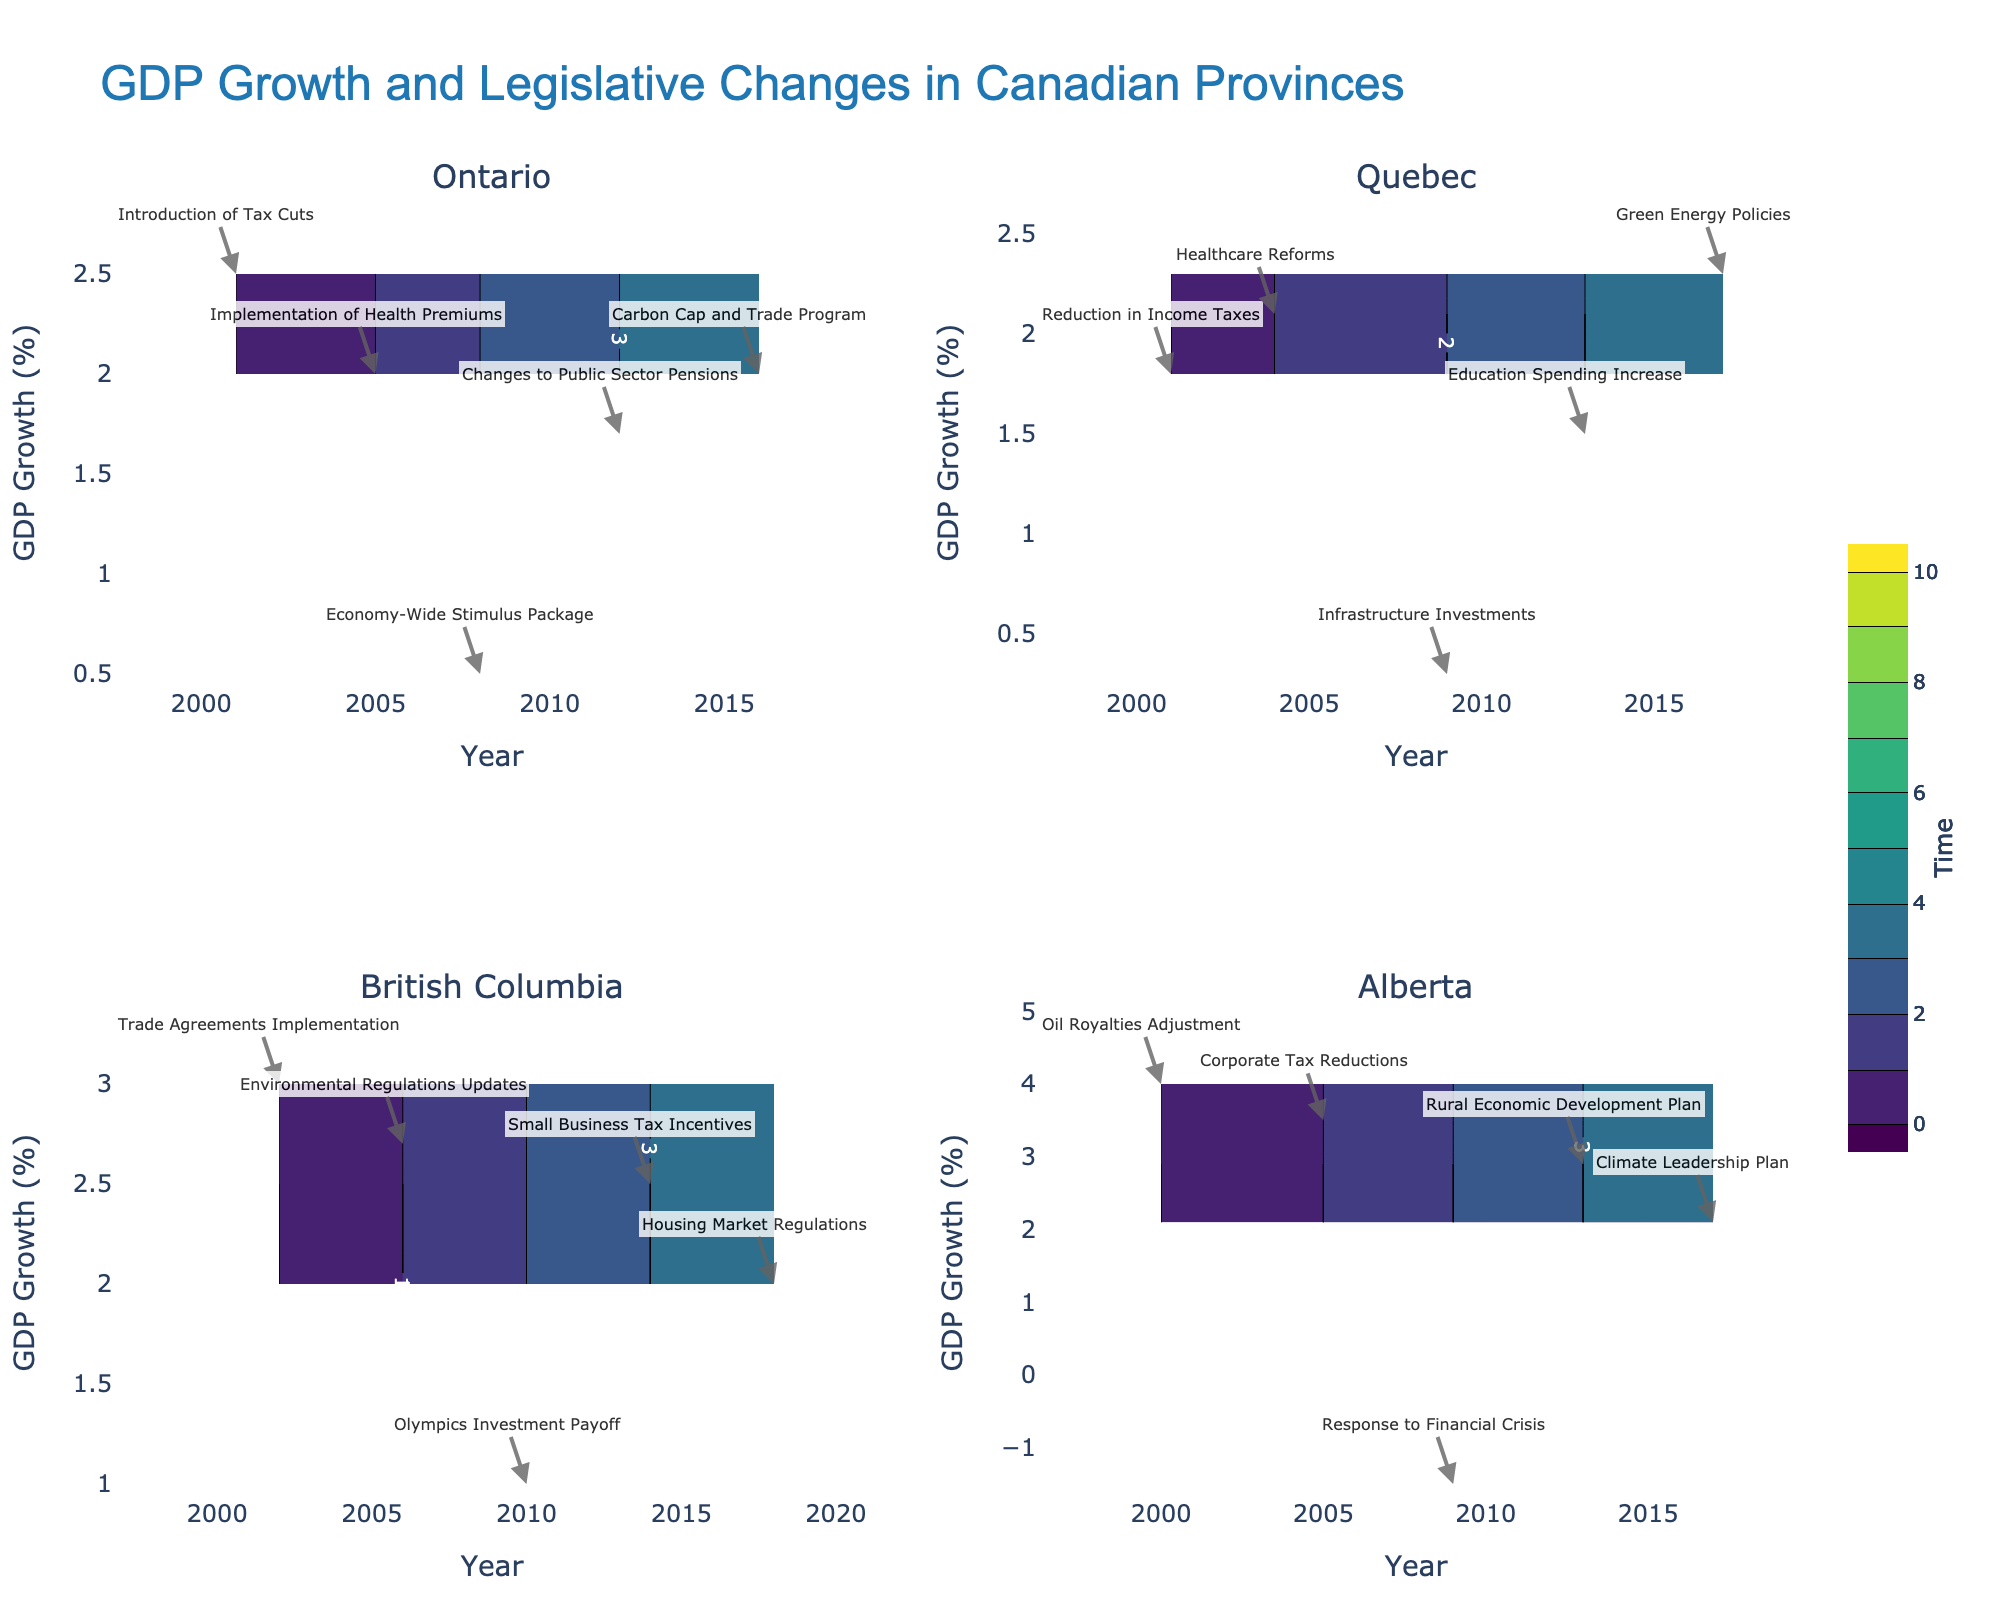What is the title of the figure? The title of the figure is displayed at the top of the chart. It reads "GDP Growth and Legislative Changes in Canadian Provinces."
Answer: GDP Growth and Legislative Changes in Canadian Provinces How many provinces' data are represented in the figure? By looking at the subplot titles, we can see there are four different provinces: Ontario, Quebec, British Columbia, and Alberta.
Answer: Four What is the color scale used in the figure? The contours are colored using the 'Viridis' color scale, a gradient of colors ranging from dark purple to yellow.
Answer: Viridis In which year did Alberta experience negative GDP growth? By examining the data points in Alberta's subplot, we see that the year corresponding to a negative GDP growth is 2009.
Answer: 2009 Which province shows the highest GDP growth rate in the figure, and what is the legislative change associated with it? Looking at the peaks of the GDP growth rates across subplots, Alberta has the highest growth rate, 4.0%, which is associated with "Oil Royalties Adjustment" in 2000.
Answer: Alberta, Oil Royalties Adjustment Comparing Ontario and Quebec, which province had a higher GDP growth rate in 2001, and by how much? In 2001, Ontario's GDP growth rate was 2.5% while Quebec's was 1.8%. The difference is 2.5% - 1.8% = 0.7%.
Answer: Ontario, 0.7% What is the average GDP growth rate for British Columbia over the years represented in the figure? British Columbia's GDP growth rates are 3.0%, 2.7%, 1.0%, 2.5%, and 2.0%. The average is calculated as (3.0 + 2.7 + 1.0 + 2.5 + 2.0) / 5 = 2.24%.
Answer: 2.24% For Quebec, which legislative change occurred closest to the year 2006? The legislative changes in Quebec close to 2006 are "Healthcare Reforms" in 2004 and "Infrastructure Investments" in 2009. The closest is "Healthcare Reforms" in 2004.
Answer: Healthcare Reforms During which legislative change did Ontario experience the lowest GDP growth rate? The lowest GDP growth rate in Ontario is 0.5% during the "Economy-Wide Stimulus Package" in 2008.
Answer: Economy-Wide Stimulus Package 